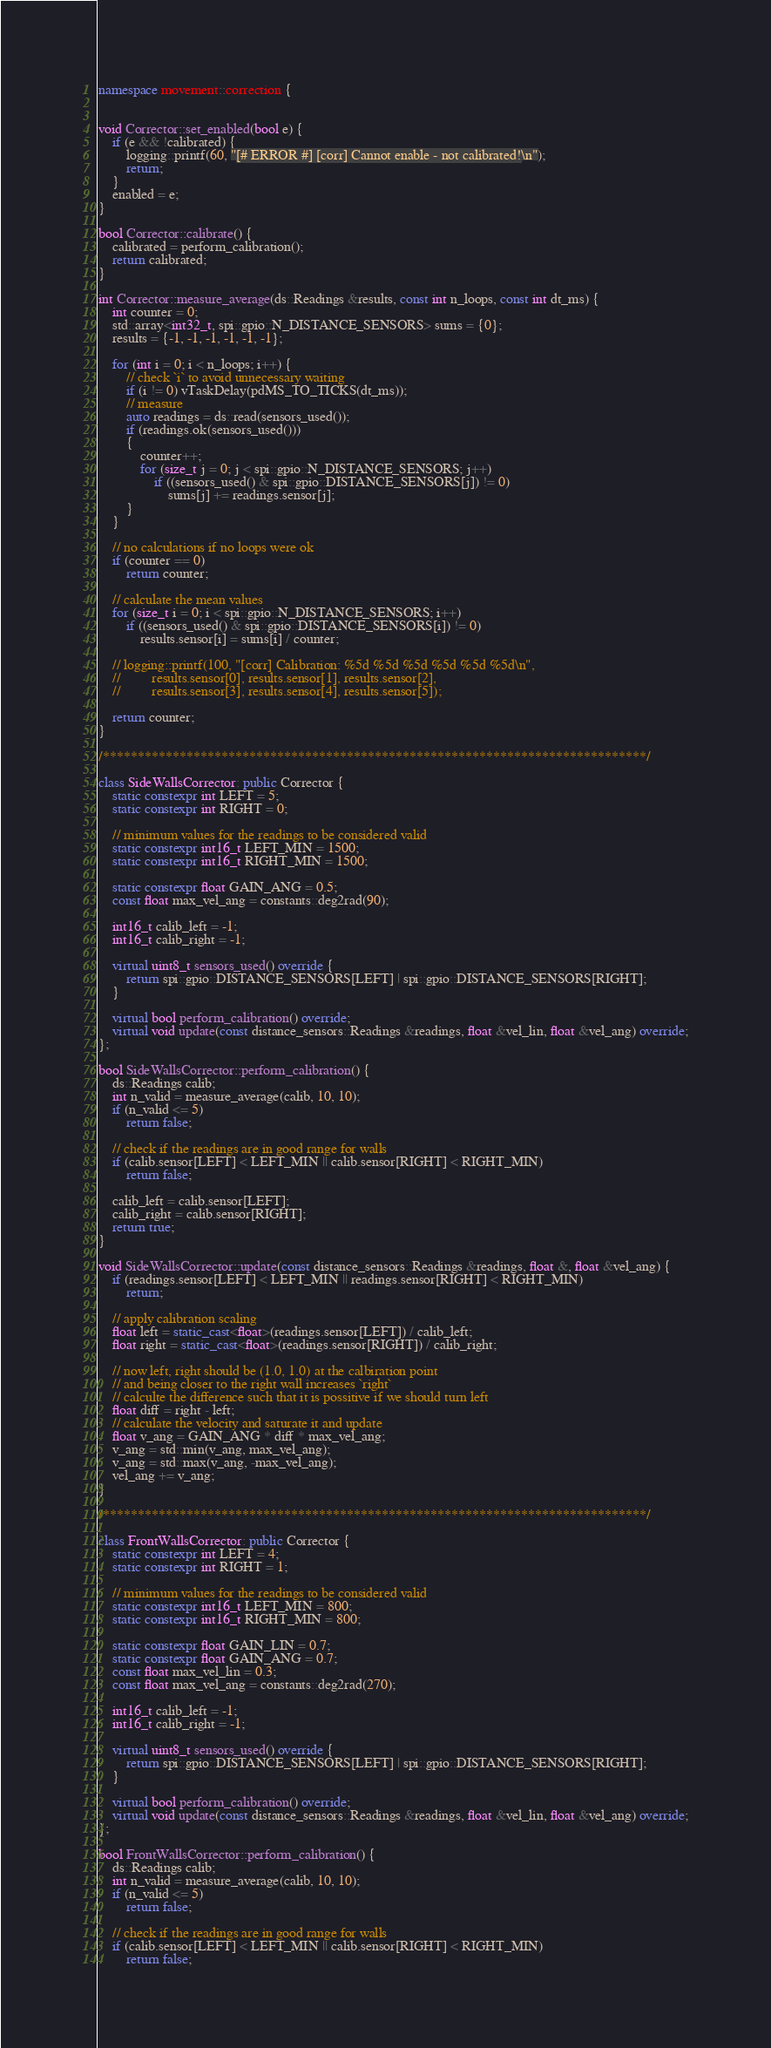<code> <loc_0><loc_0><loc_500><loc_500><_C++_>namespace movement::correction {


void Corrector::set_enabled(bool e) {
    if (e && !calibrated) {
        logging::printf(60, "[# ERROR #] [corr] Cannot enable - not calibrated!\n");
        return;
    }
    enabled = e;
}

bool Corrector::calibrate() {
    calibrated = perform_calibration();
    return calibrated;
}

int Corrector::measure_average(ds::Readings &results, const int n_loops, const int dt_ms) {
    int counter = 0;
    std::array<int32_t, spi::gpio::N_DISTANCE_SENSORS> sums = {0};
    results = {-1, -1, -1, -1, -1, -1};

    for (int i = 0; i < n_loops; i++) {
        // check `i` to avoid unnecessary waiting
        if (i != 0) vTaskDelay(pdMS_TO_TICKS(dt_ms));
        // measure
        auto readings = ds::read(sensors_used());
        if (readings.ok(sensors_used()))
        {
            counter++;
            for (size_t j = 0; j < spi::gpio::N_DISTANCE_SENSORS; j++)
                if ((sensors_used() & spi::gpio::DISTANCE_SENSORS[j]) != 0)
                    sums[j] += readings.sensor[j];
        }
    }

    // no calculations if no loops were ok
    if (counter == 0)
        return counter;

    // calculate the mean values
    for (size_t i = 0; i < spi::gpio::N_DISTANCE_SENSORS; i++)
        if ((sensors_used() & spi::gpio::DISTANCE_SENSORS[i]) != 0)
            results.sensor[i] = sums[i] / counter;

    // logging::printf(100, "[corr] Calibration: %5d %5d %5d %5d %5d %5d\n",
    //         results.sensor[0], results.sensor[1], results.sensor[2],
    //         results.sensor[3], results.sensor[4], results.sensor[5]);

    return counter;
}

/******************************************************************************/

class SideWallsCorrector: public Corrector {
    static constexpr int LEFT = 5;
    static constexpr int RIGHT = 0;

    // minimum values for the readings to be considered valid
    static constexpr int16_t LEFT_MIN = 1500;
    static constexpr int16_t RIGHT_MIN = 1500;

    static constexpr float GAIN_ANG = 0.5;
    const float max_vel_ang = constants::deg2rad(90);

    int16_t calib_left = -1;
    int16_t calib_right = -1;

    virtual uint8_t sensors_used() override {
        return spi::gpio::DISTANCE_SENSORS[LEFT] | spi::gpio::DISTANCE_SENSORS[RIGHT];
    }

    virtual bool perform_calibration() override;
    virtual void update(const distance_sensors::Readings &readings, float &vel_lin, float &vel_ang) override;
};

bool SideWallsCorrector::perform_calibration() {
    ds::Readings calib;
    int n_valid = measure_average(calib, 10, 10);
    if (n_valid <= 5)
        return false;

    // check if the readings are in good range for walls
    if (calib.sensor[LEFT] < LEFT_MIN || calib.sensor[RIGHT] < RIGHT_MIN)
        return false;

    calib_left = calib.sensor[LEFT];
    calib_right = calib.sensor[RIGHT];
    return true;
}

void SideWallsCorrector::update(const distance_sensors::Readings &readings, float &, float &vel_ang) {
    if (readings.sensor[LEFT] < LEFT_MIN || readings.sensor[RIGHT] < RIGHT_MIN)
        return;

    // apply calibration scaling
    float left = static_cast<float>(readings.sensor[LEFT]) / calib_left;
    float right = static_cast<float>(readings.sensor[RIGHT]) / calib_right;

    // now left, right should be (1.0, 1.0) at the calbiration point
    // and being closer to the right wall increases `right`
    // calculte the difference such that it is possitive if we should turn left
    float diff = right - left;
    // calculate the velocity and saturate it and update
    float v_ang = GAIN_ANG * diff * max_vel_ang;
    v_ang = std::min(v_ang, max_vel_ang);
    v_ang = std::max(v_ang, -max_vel_ang);
    vel_ang += v_ang;
}

/******************************************************************************/

class FrontWallsCorrector: public Corrector {
    static constexpr int LEFT = 4;
    static constexpr int RIGHT = 1;

    // minimum values for the readings to be considered valid
    static constexpr int16_t LEFT_MIN = 800;
    static constexpr int16_t RIGHT_MIN = 800;

    static constexpr float GAIN_LIN = 0.7;
    static constexpr float GAIN_ANG = 0.7;
    const float max_vel_lin = 0.3;
    const float max_vel_ang = constants::deg2rad(270);

    int16_t calib_left = -1;
    int16_t calib_right = -1;

    virtual uint8_t sensors_used() override {
        return spi::gpio::DISTANCE_SENSORS[LEFT] | spi::gpio::DISTANCE_SENSORS[RIGHT];
    }

    virtual bool perform_calibration() override;
    virtual void update(const distance_sensors::Readings &readings, float &vel_lin, float &vel_ang) override;
};

bool FrontWallsCorrector::perform_calibration() {
    ds::Readings calib;
    int n_valid = measure_average(calib, 10, 10);
    if (n_valid <= 5)
        return false;

    // check if the readings are in good range for walls
    if (calib.sensor[LEFT] < LEFT_MIN || calib.sensor[RIGHT] < RIGHT_MIN)
        return false;
</code> 